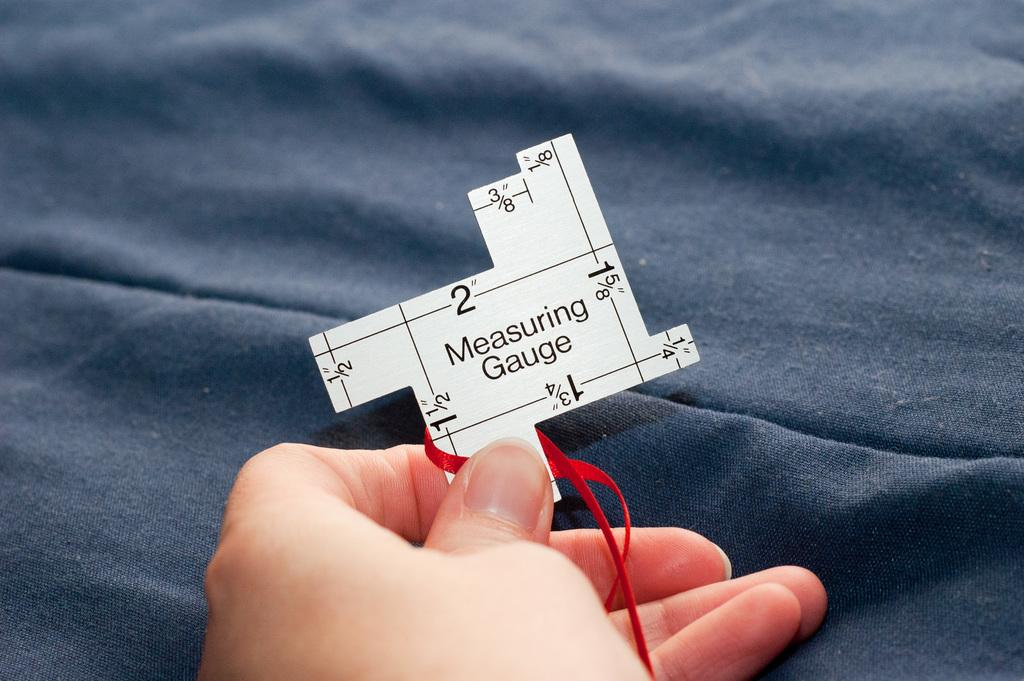What is being held by the hand in the image? The hand is holding a paper. What is on the paper that the hand is holding? The paper contains numbers and text. How many ducks are visible in the image? There are no ducks present in the image. What is the temperature in the room where the image was taken? The provided facts do not mention the temperature or any information about the room where the image was taken. 